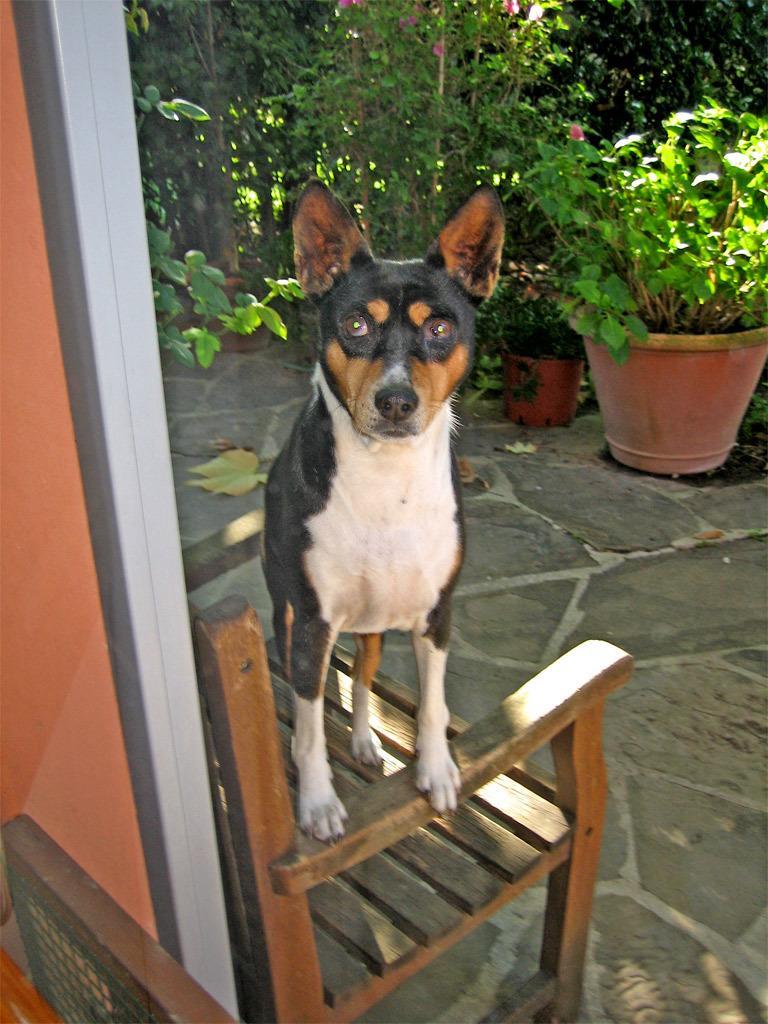Could you give a brief overview of what you see in this image? A dog is looking at a camera while standing on a chair. There few plant pots and plants behind it. 